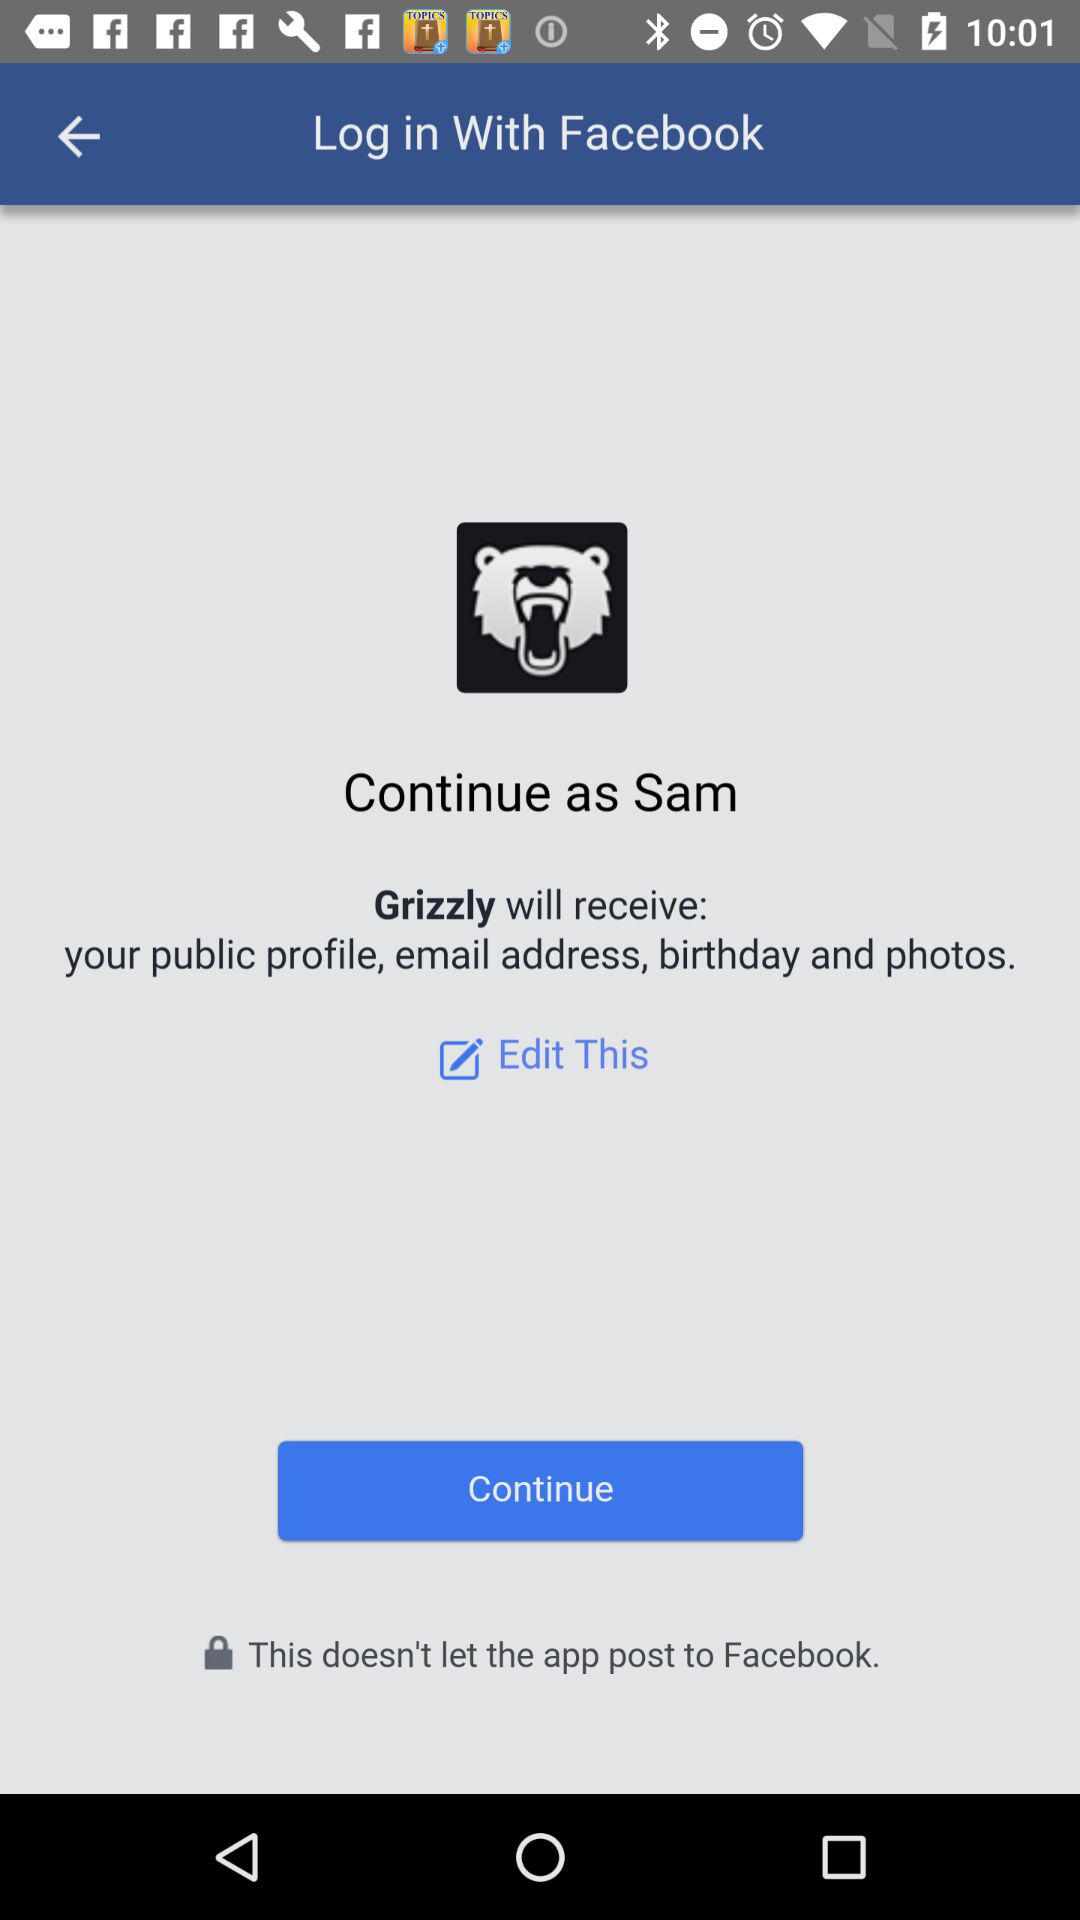What application will receive the public profile, birthday, photos and email address? The public profile, birthday, photos and email address will be received by "Grizzly". 